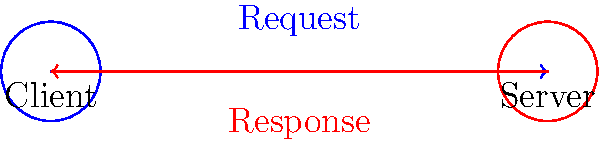In the simple client-server network topology shown above, what is the typical sequence of packet flow for a basic request-response interaction? Describe the process in terms of source, destination, and direction of data flow. To understand the packet flow in a basic client-server interaction, let's break it down step-by-step:

1. Initial state: The client and server are both idle, waiting for communication to begin.

2. Client request:
   a. The client initiates the communication by sending a request packet.
   b. The source of this packet is the client.
   c. The destination of this packet is the server.
   d. The direction of data flow is from client to server (left to right in the diagram).

3. Server processing:
   a. The server receives the request packet.
   b. It processes the request and prepares a response.

4. Server response:
   a. The server sends a response packet back to the client.
   b. The source of this packet is the server.
   c. The destination of this packet is the client.
   d. The direction of data flow is from server to client (right to left in the diagram).

5. Client reception:
   a. The client receives the response packet.
   b. It processes the response, completing the interaction.

This sequence represents a single request-response cycle. In real-world scenarios, multiple such cycles may occur in a single client-server session.

The packet flow can be summarized as:
Client (source) → Server (destination) → Server (source) → Client (destination)
Answer: Client to server, then server to client 